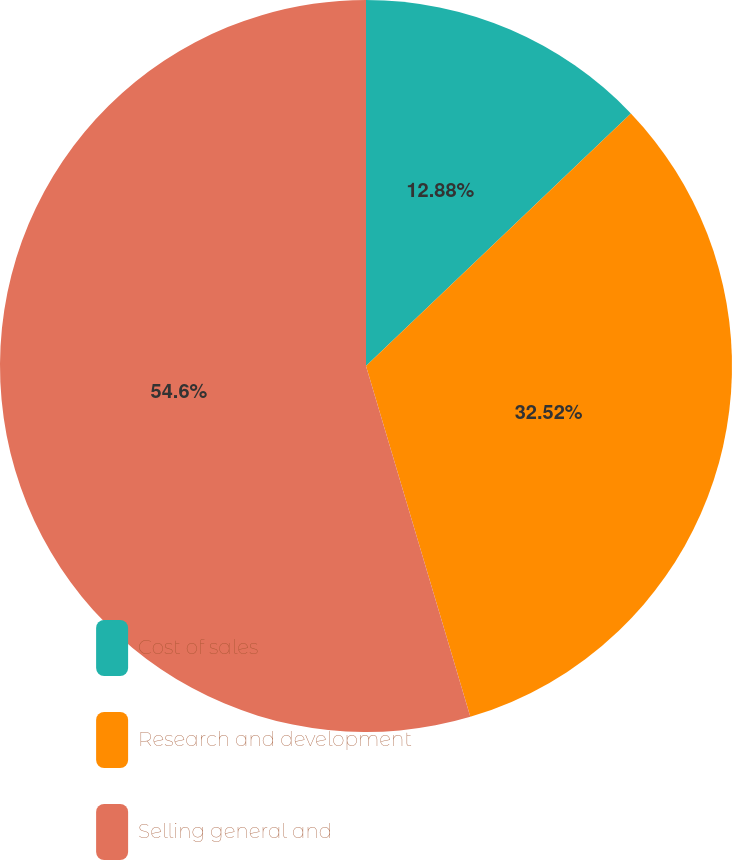Convert chart to OTSL. <chart><loc_0><loc_0><loc_500><loc_500><pie_chart><fcel>Cost of sales<fcel>Research and development<fcel>Selling general and<nl><fcel>12.88%<fcel>32.52%<fcel>54.6%<nl></chart> 